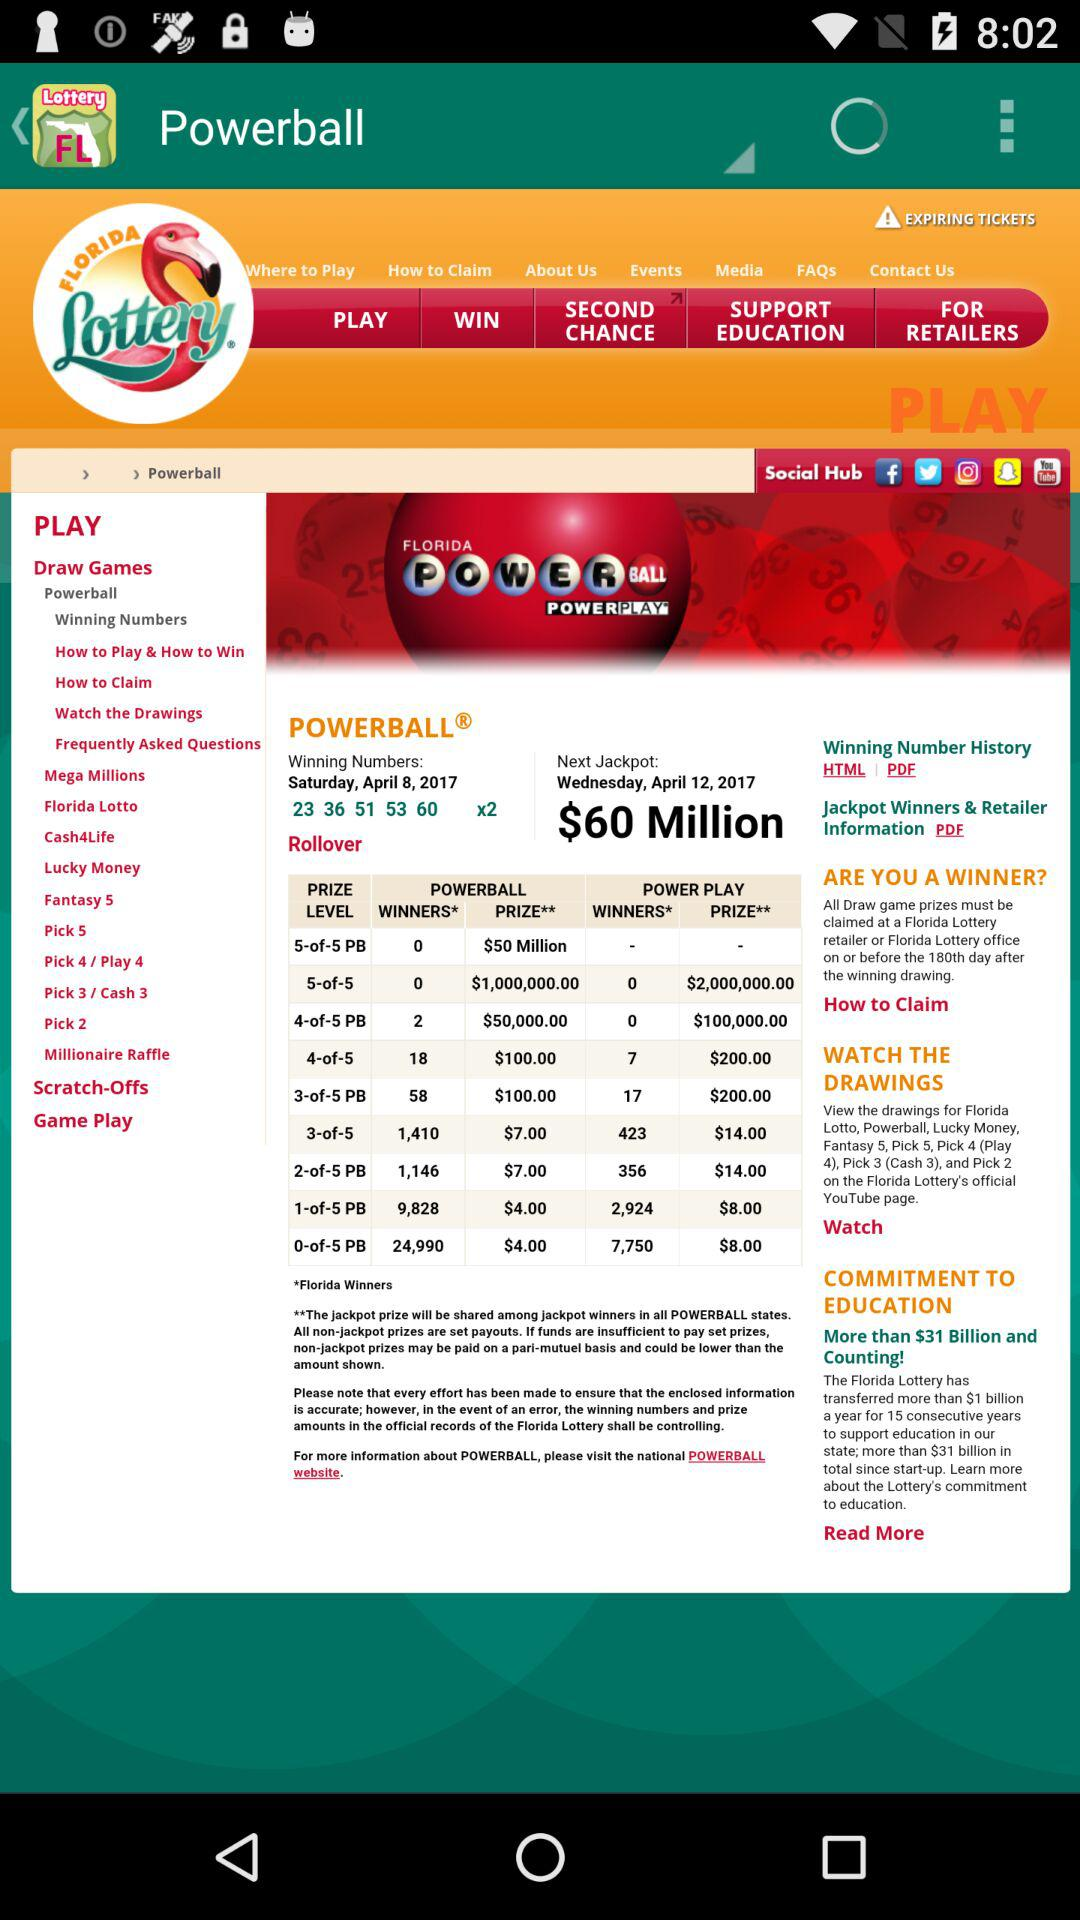On what day is the next jackpot opening? The next jackpot opening is on Wednesday. 